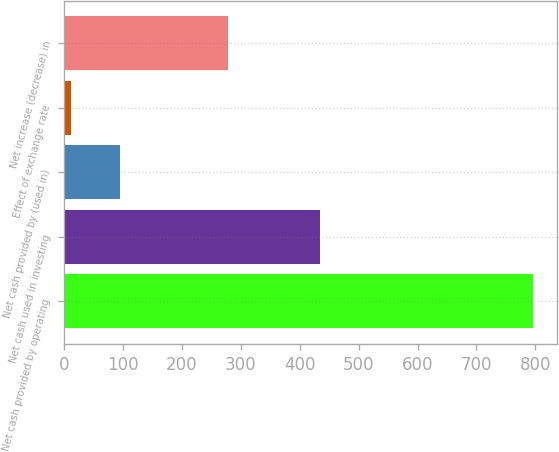Convert chart. <chart><loc_0><loc_0><loc_500><loc_500><bar_chart><fcel>Net cash provided by operating<fcel>Net cash used in investing<fcel>Net cash provided by (used in)<fcel>Effect of exchange rate<fcel>Net increase (decrease) in<nl><fcel>796.1<fcel>434.6<fcel>95.2<fcel>11.9<fcel>278.2<nl></chart> 